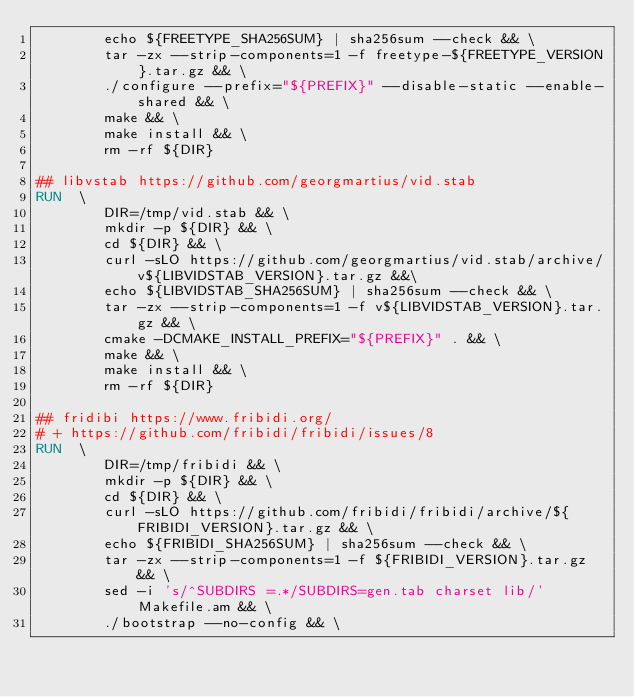Convert code to text. <code><loc_0><loc_0><loc_500><loc_500><_Dockerfile_>        echo ${FREETYPE_SHA256SUM} | sha256sum --check && \
        tar -zx --strip-components=1 -f freetype-${FREETYPE_VERSION}.tar.gz && \
        ./configure --prefix="${PREFIX}" --disable-static --enable-shared && \
        make && \
        make install && \
        rm -rf ${DIR}

## libvstab https://github.com/georgmartius/vid.stab
RUN  \
        DIR=/tmp/vid.stab && \
        mkdir -p ${DIR} && \
        cd ${DIR} && \
        curl -sLO https://github.com/georgmartius/vid.stab/archive/v${LIBVIDSTAB_VERSION}.tar.gz &&\
        echo ${LIBVIDSTAB_SHA256SUM} | sha256sum --check && \
        tar -zx --strip-components=1 -f v${LIBVIDSTAB_VERSION}.tar.gz && \
        cmake -DCMAKE_INSTALL_PREFIX="${PREFIX}" . && \
        make && \
        make install && \
        rm -rf ${DIR}

## fridibi https://www.fribidi.org/
# + https://github.com/fribidi/fribidi/issues/8
RUN  \
        DIR=/tmp/fribidi && \
        mkdir -p ${DIR} && \
        cd ${DIR} && \
        curl -sLO https://github.com/fribidi/fribidi/archive/${FRIBIDI_VERSION}.tar.gz && \
        echo ${FRIBIDI_SHA256SUM} | sha256sum --check && \
        tar -zx --strip-components=1 -f ${FRIBIDI_VERSION}.tar.gz && \
        sed -i 's/^SUBDIRS =.*/SUBDIRS=gen.tab charset lib/' Makefile.am && \
        ./bootstrap --no-config && \</code> 